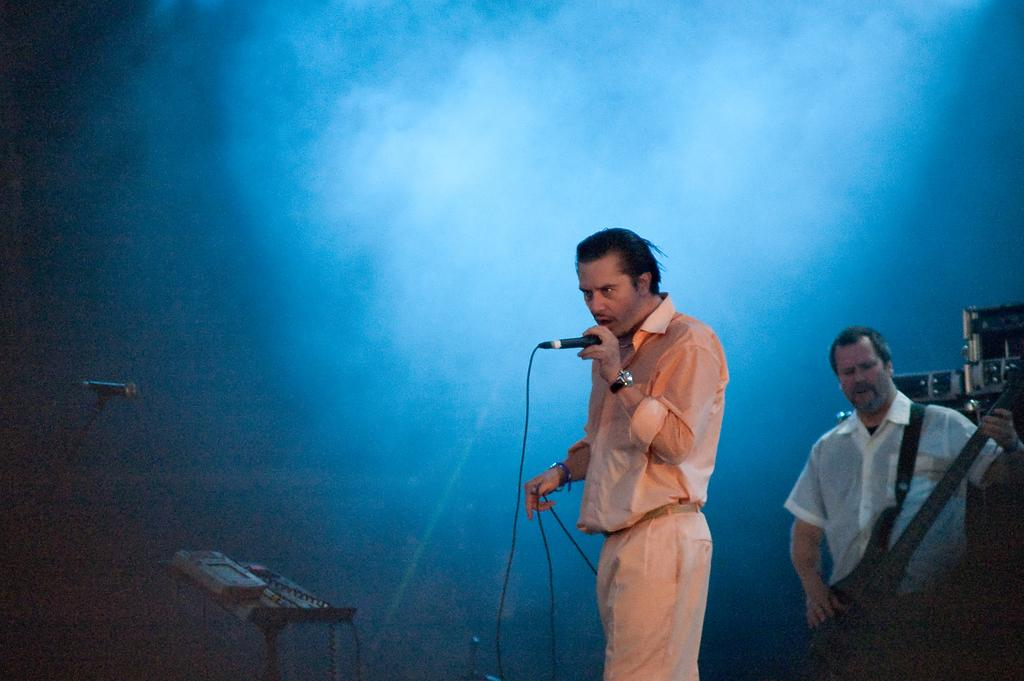What is the man in the image doing? The man is standing and singing into a microphone. Can you describe the other person in the image? The other person is standing in the background and playing a guitar. What objects are visible in the image that are not musical instruments? Briefcases are visible in the image. What type of meal is being prepared by the cook in the image? There is no cook or meal preparation visible in the image. How many balls are present in the image? There are no balls present in the image. 